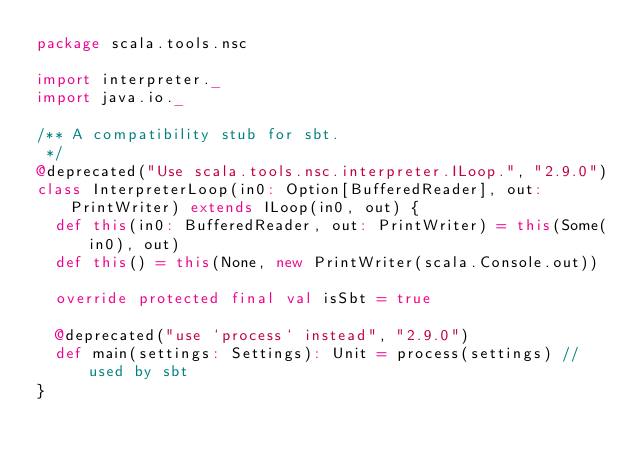<code> <loc_0><loc_0><loc_500><loc_500><_Scala_>package scala.tools.nsc

import interpreter._
import java.io._

/** A compatibility stub for sbt.
 */
@deprecated("Use scala.tools.nsc.interpreter.ILoop.", "2.9.0")
class InterpreterLoop(in0: Option[BufferedReader], out: PrintWriter) extends ILoop(in0, out) {
  def this(in0: BufferedReader, out: PrintWriter) = this(Some(in0), out)
  def this() = this(None, new PrintWriter(scala.Console.out))

  override protected final val isSbt = true

  @deprecated("use `process` instead", "2.9.0")
  def main(settings: Settings): Unit = process(settings) //used by sbt
}
</code> 